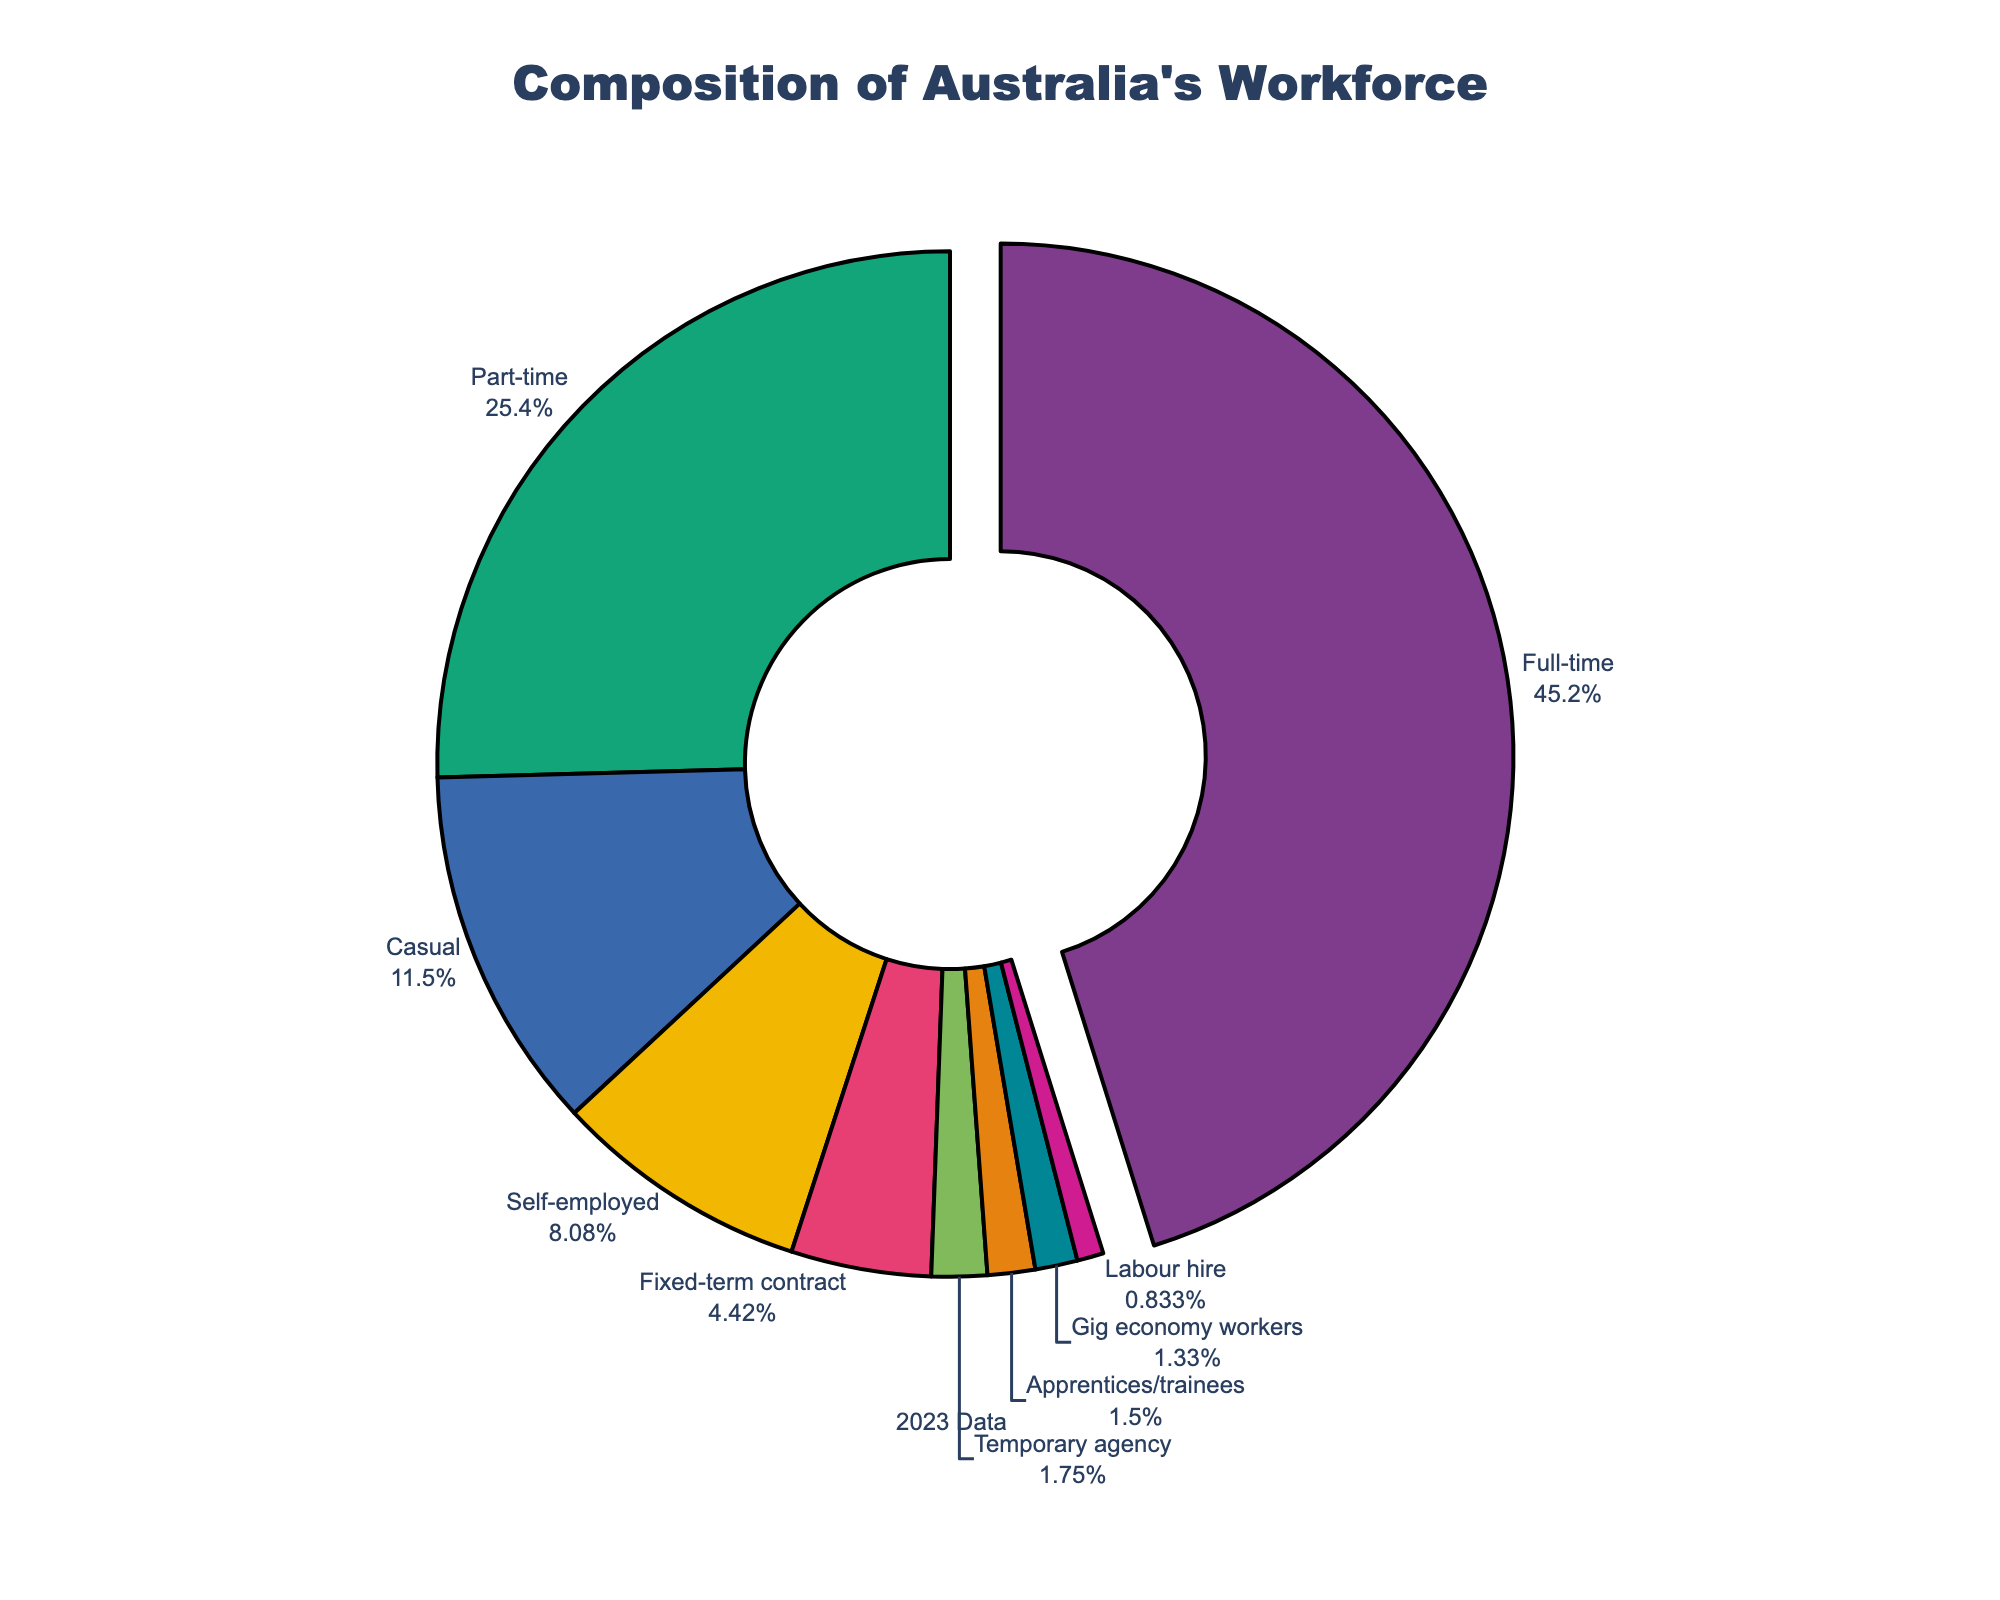What percentage of Australia's workforce is either full-time or part-time employment? To find this, we sum the percentages of full-time (54.2%) and part-time (30.5%) employment: 54.2 + 30.5 = 84.7.
Answer: 84.7% Which employment type occupies the smallest share in Australia's workforce? By examining the chart, we find that "Labour hire" is the smallest segment, representing 1.0% of the workforce.
Answer: Labour hire How does the percentage of self-employed workers compare to the percentage of casual workers? The percentage of self-employed workers is 9.7%, while casual workers account for 13.8%. Comparing these values: 9.7 < 13.8.
Answer: Less than casual What's the combined percentage of workers on a fixed-term contract and temporary agency workers? Add the percentage of fixed-term contract (5.3%) to temporary agency workers (2.1%): 5.3 + 2.1 = 7.4.
Answer: 7.4% Which employment type has the largest visual segment in the pie chart? The largest segment visually corresponds to full-time employment, which is highlighted by being slightly pulled out from the chart.
Answer: Full-time Compare the percentage of gig economy workers to apprentices/trainees. Which is higher, and by how much? Apprentices/trainees account for 1.8% of the workforce, while gig economy workers make up 1.6%. The difference is: 1.8 - 1.6 = 0.2.
Answer: Apprentices/trainees by 0.2% What is the total percentage of employment types that individually make up less than 2% of the workforce? Sum the percentages of gig economy workers (1.6%), apprentices/trainees (1.8%), and labour hire (1.0%): 1.6 + 1.8 + 1.0 = 4.4.
Answer: 4.4% Is the number of self-employed workers greater than the number of temporary agency workers and labour hire workers combined? Temporary agency workers make up 2.1%, and labour hire workers make up 1.0%, totaling 3.1%. Self-employed workers are 9.7%, which is greater: 9.7 > 3.1.
Answer: Yes How much larger is the percentage of part-time workers compared to casual workers? The percentage of part-time workers is 30.5%, and for casual workers, it is 13.8%. The difference is: 30.5 - 13.8 = 16.7.
Answer: 16.7% 